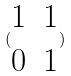Convert formula to latex. <formula><loc_0><loc_0><loc_500><loc_500>( \begin{matrix} 1 & 1 \\ 0 & 1 \end{matrix} )</formula> 